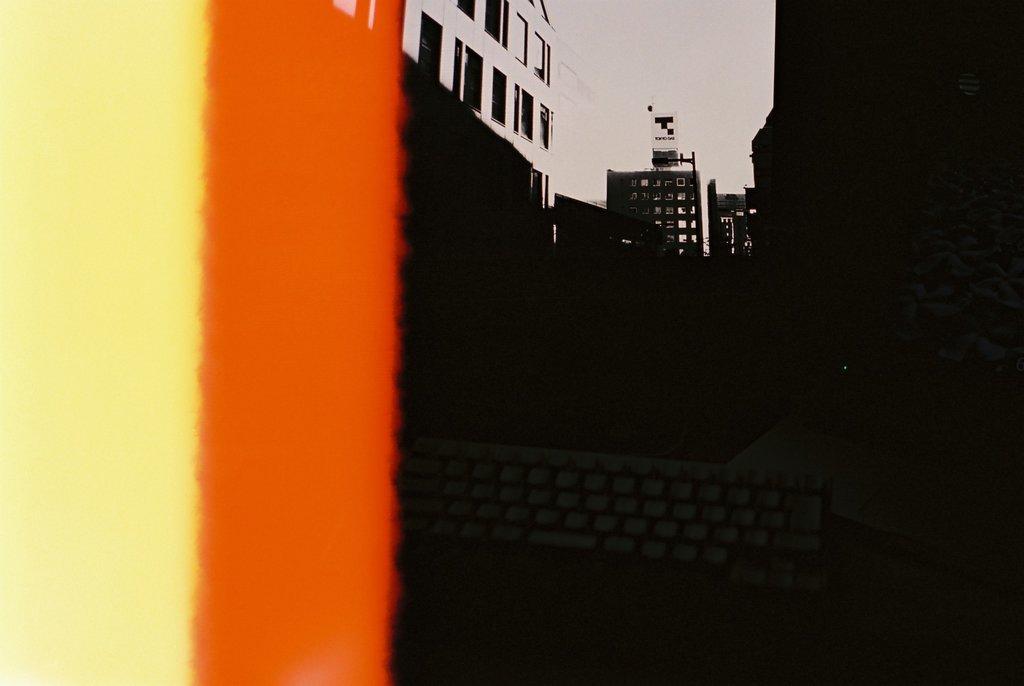In one or two sentences, can you explain what this image depicts? In this picture we can see buildings in the background, there is the sky at the top of the picture. 